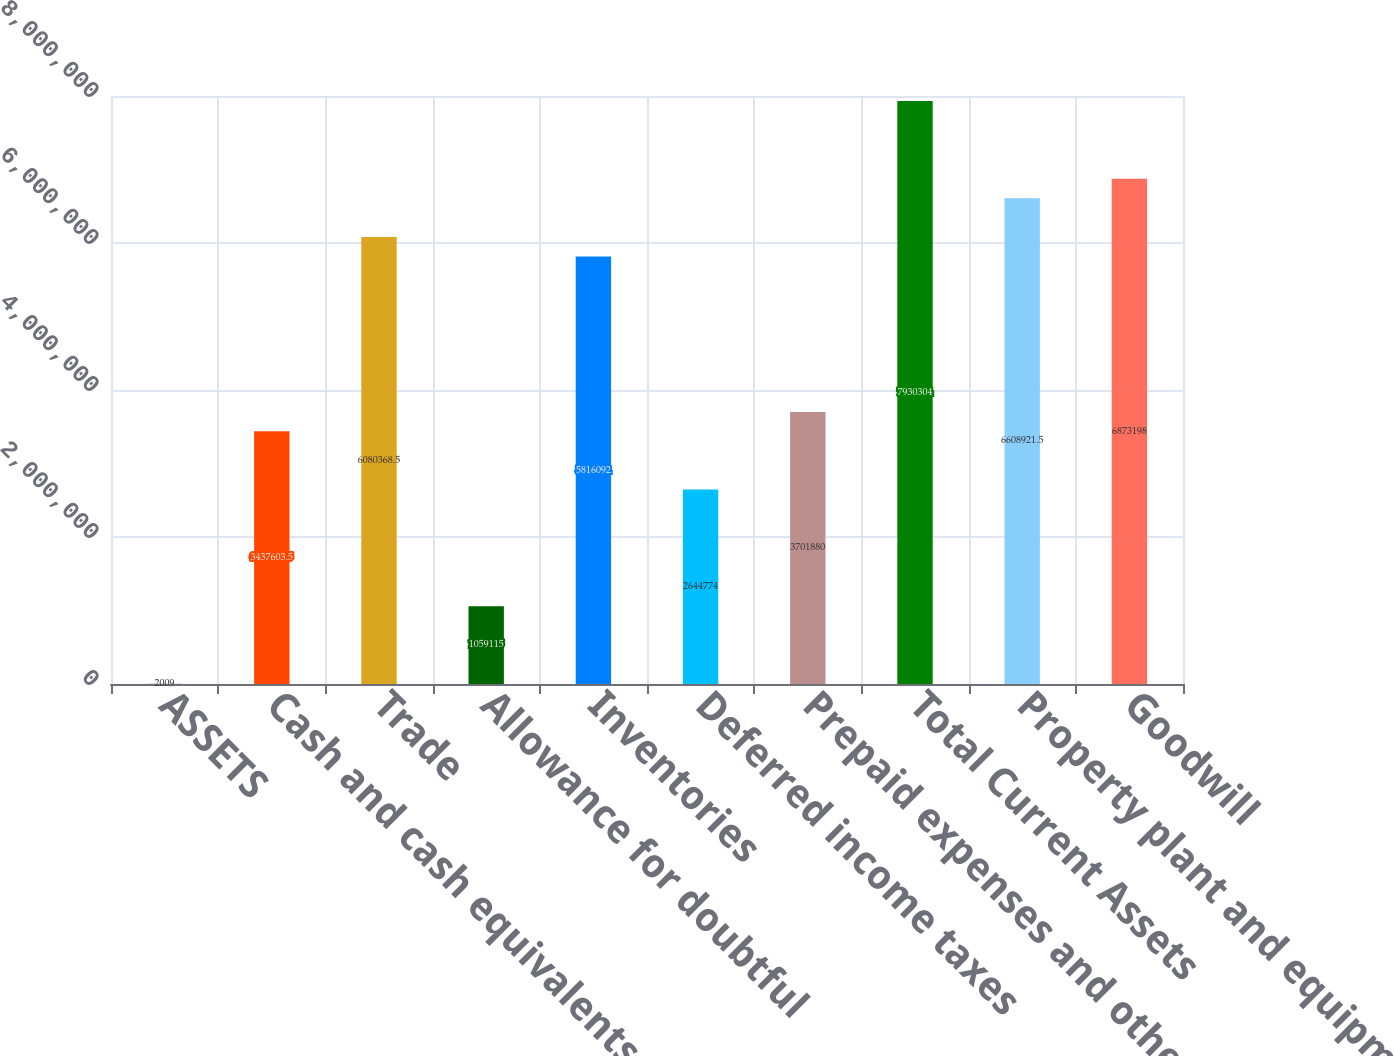<chart> <loc_0><loc_0><loc_500><loc_500><bar_chart><fcel>ASSETS<fcel>Cash and cash equivalents<fcel>Trade<fcel>Allowance for doubtful<fcel>Inventories<fcel>Deferred income taxes<fcel>Prepaid expenses and other<fcel>Total Current Assets<fcel>Property plant and equipment<fcel>Goodwill<nl><fcel>2009<fcel>3.4376e+06<fcel>6.08037e+06<fcel>1.05912e+06<fcel>5.81609e+06<fcel>2.64477e+06<fcel>3.70188e+06<fcel>7.9303e+06<fcel>6.60892e+06<fcel>6.8732e+06<nl></chart> 